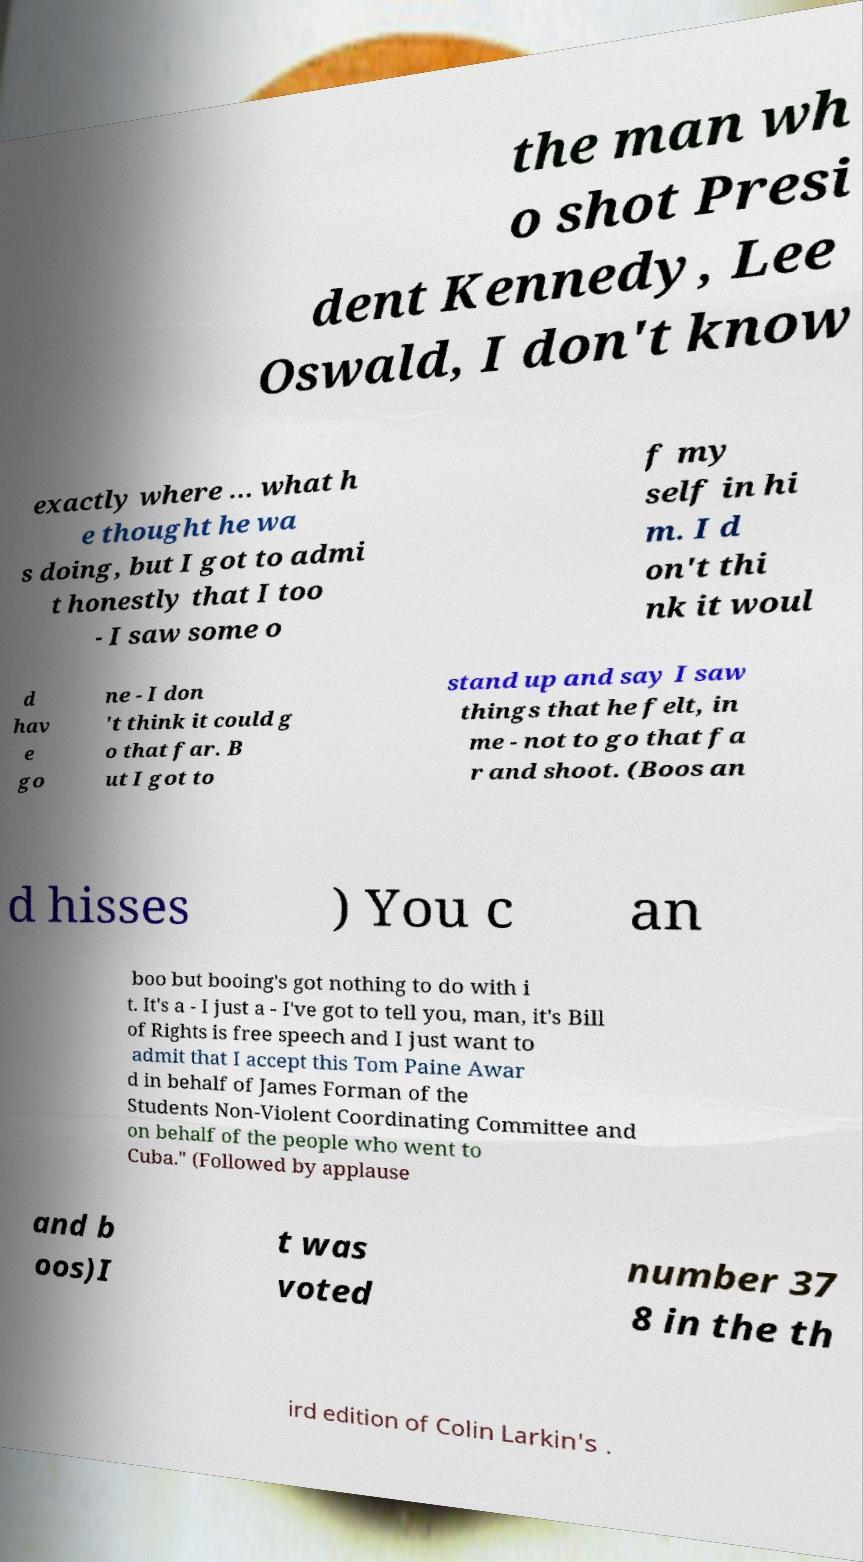Please read and relay the text visible in this image. What does it say? the man wh o shot Presi dent Kennedy, Lee Oswald, I don't know exactly where … what h e thought he wa s doing, but I got to admi t honestly that I too - I saw some o f my self in hi m. I d on't thi nk it woul d hav e go ne - I don 't think it could g o that far. B ut I got to stand up and say I saw things that he felt, in me - not to go that fa r and shoot. (Boos an d hisses ) You c an boo but booing's got nothing to do with i t. It's a - I just a - I've got to tell you, man, it's Bill of Rights is free speech and I just want to admit that I accept this Tom Paine Awar d in behalf of James Forman of the Students Non-Violent Coordinating Committee and on behalf of the people who went to Cuba." (Followed by applause and b oos)I t was voted number 37 8 in the th ird edition of Colin Larkin's . 